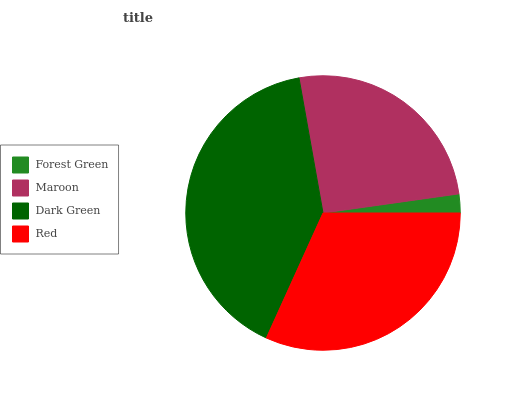Is Forest Green the minimum?
Answer yes or no. Yes. Is Dark Green the maximum?
Answer yes or no. Yes. Is Maroon the minimum?
Answer yes or no. No. Is Maroon the maximum?
Answer yes or no. No. Is Maroon greater than Forest Green?
Answer yes or no. Yes. Is Forest Green less than Maroon?
Answer yes or no. Yes. Is Forest Green greater than Maroon?
Answer yes or no. No. Is Maroon less than Forest Green?
Answer yes or no. No. Is Red the high median?
Answer yes or no. Yes. Is Maroon the low median?
Answer yes or no. Yes. Is Dark Green the high median?
Answer yes or no. No. Is Forest Green the low median?
Answer yes or no. No. 